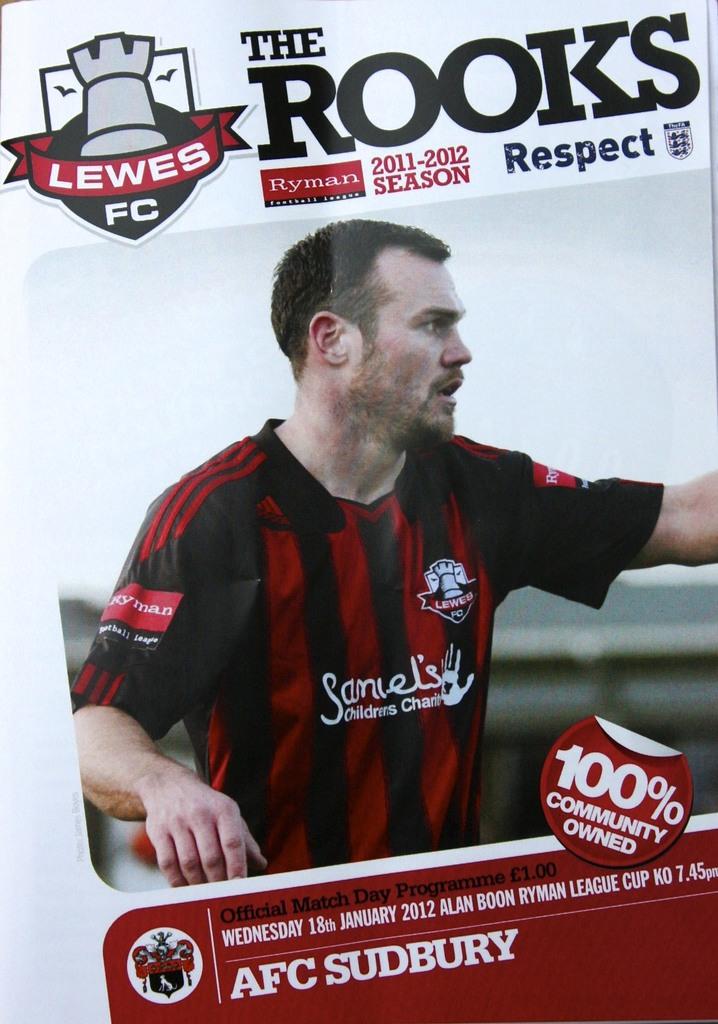What is the name of the booklet?
Your answer should be compact. The rooks. What percent is this community owned?
Your answer should be very brief. 100. 